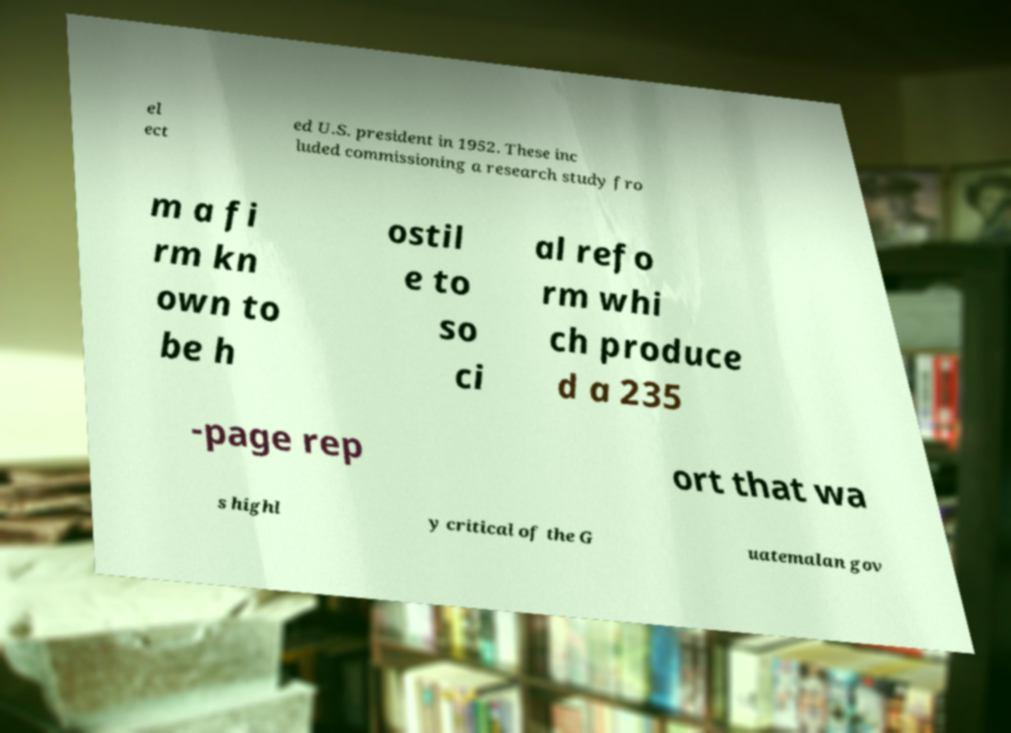Can you accurately transcribe the text from the provided image for me? el ect ed U.S. president in 1952. These inc luded commissioning a research study fro m a fi rm kn own to be h ostil e to so ci al refo rm whi ch produce d a 235 -page rep ort that wa s highl y critical of the G uatemalan gov 